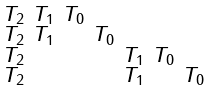<formula> <loc_0><loc_0><loc_500><loc_500>\begin{smallmatrix} T _ { 2 } & T _ { 1 } & T _ { 0 } & & & & \\ T _ { 2 } & T _ { 1 } & & T _ { 0 } & & & \\ T _ { 2 } & & & & T _ { 1 } & T _ { 0 } & \\ T _ { 2 } & & & & T _ { 1 } & & T _ { 0 } \end{smallmatrix}</formula> 